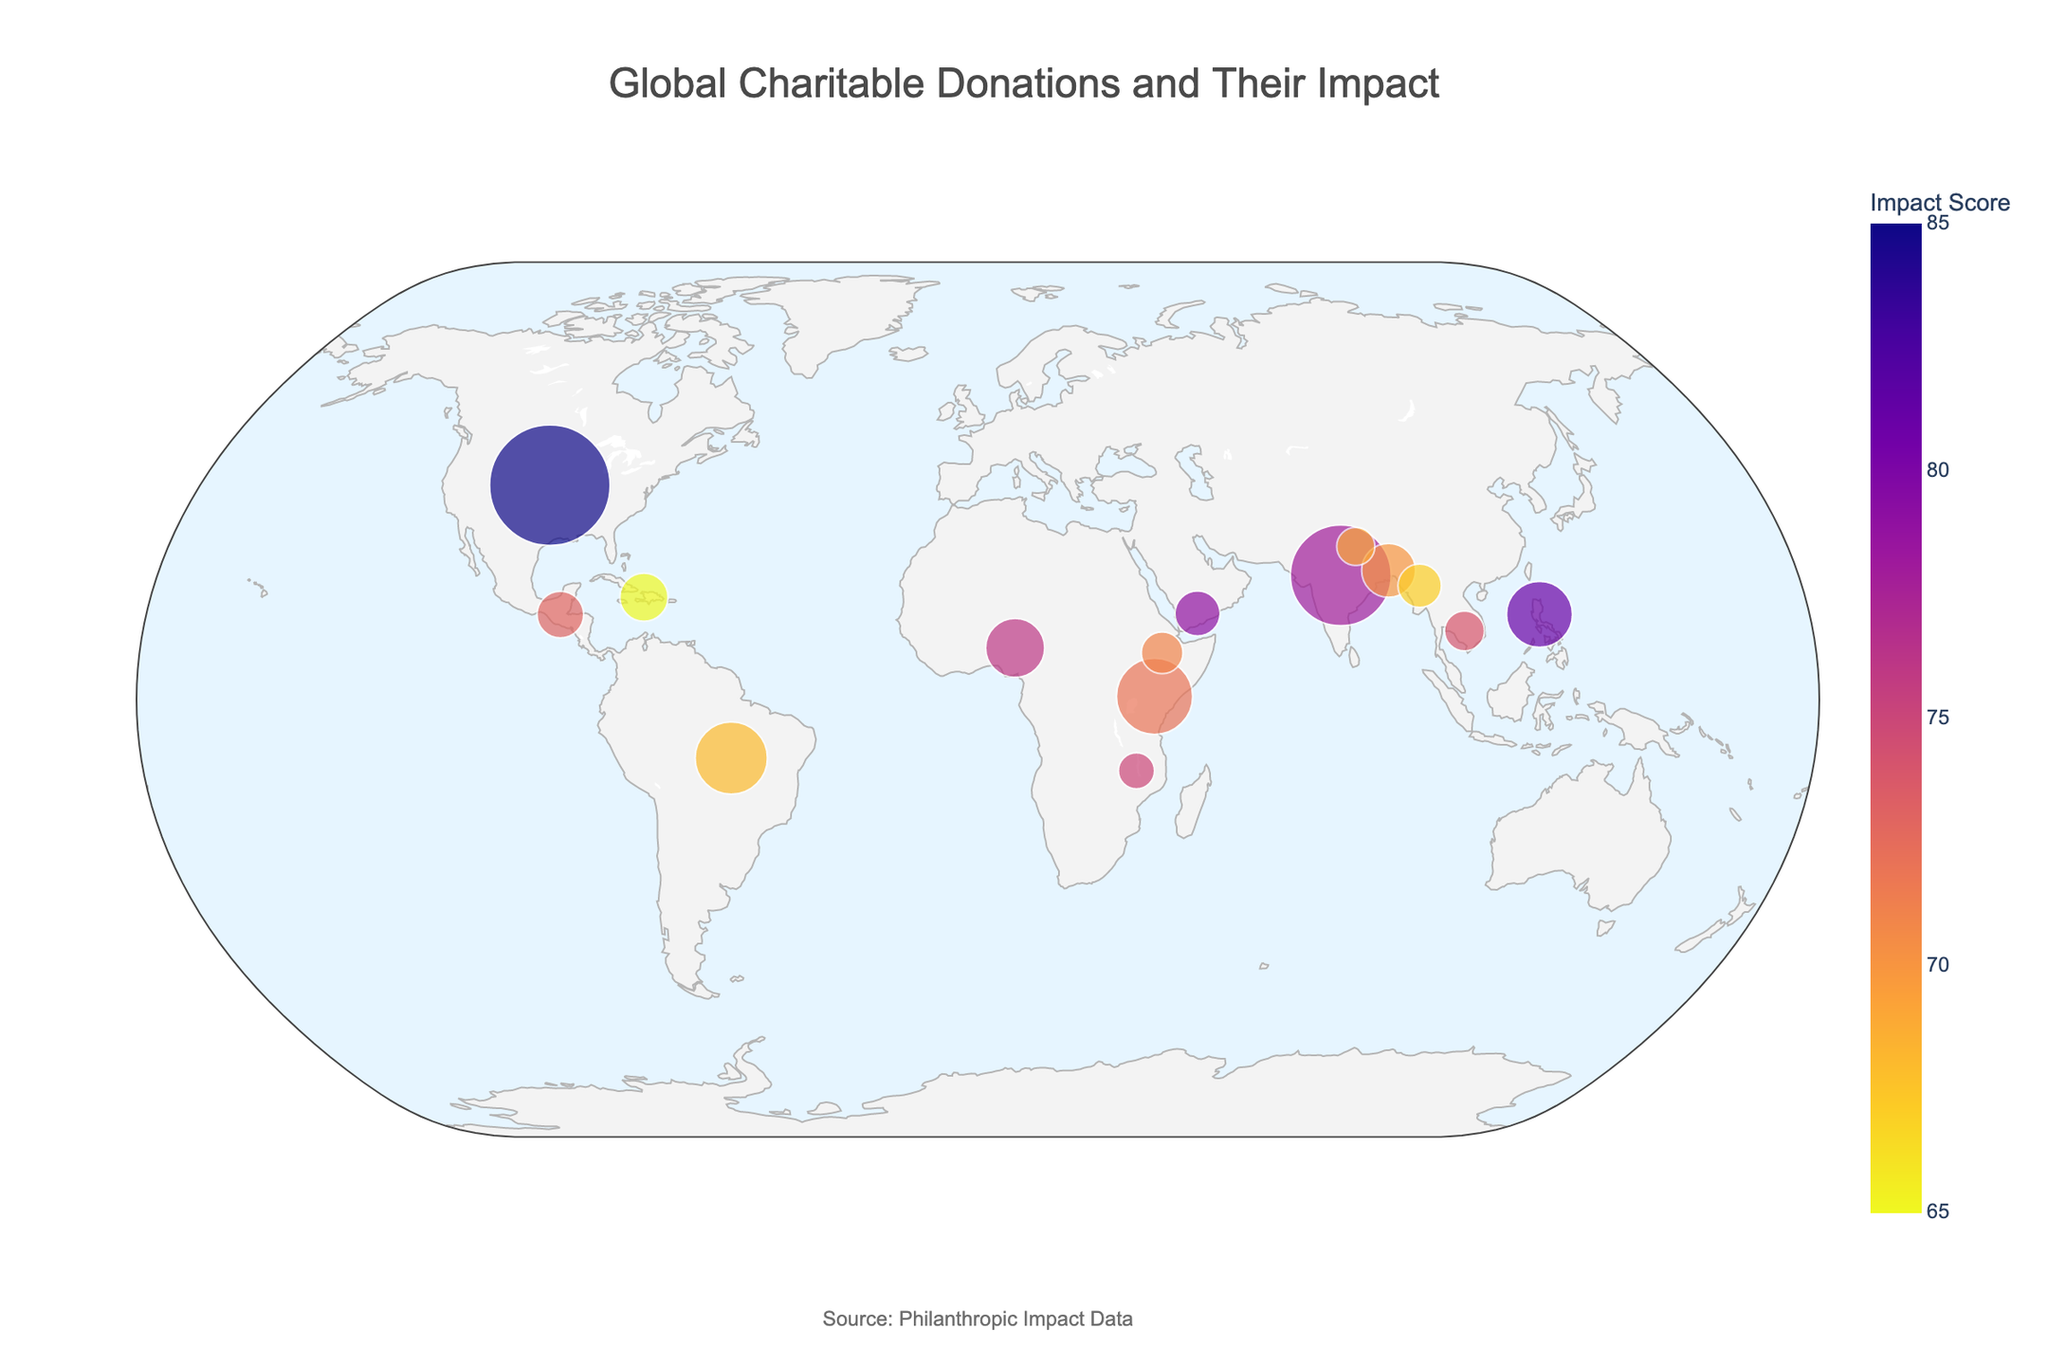What is the title of the figure? The title is typically placed prominently at the top of the figure. In this case, it states the main focus of the figure.
Answer: Global Charitable Donations and Their Impact What are the primary impact areas highlighted for donations in India and Kenya? By looking at the hover information of the points representing different countries, you can see the primary impact areas. For India, it is 'Healthcare' and for Kenya, it is 'Poverty Alleviation'.
Answer: Healthcare for India and Poverty Alleviation for Kenya How does the donation amount to the United States compare to that of Brazil? To compare donation amounts, check the sizes of the points on the map. The United States has a larger point compared to Brazil, meaning it received a higher donation amount. The specific amounts are $5,000,000 and $1,800,000, respectively.
Answer: The United States received more donations than Brazil What's the average Impact Score of donations made to Bangladesh, Guatemala, and Malawi? First, find the Impact Scores for each country: Bangladesh (70), Guatemala (73), and Malawi (75). Add these scores (70 + 73 + 75 = 218) and divide by the number of countries (218 / 3 = 72.67).
Answer: 72.67 Which country received the smallest donation amount? By looking at the smallest sized dot on the map and checking the hover information, the smallest donation amount is to Malawi, which is $450,000.
Answer: Malawi Which country targeting 'Child Welfare' has received donations and what is its Impact Score? Hover over the points to find the country targeting 'Child Welfare'. Guatemala is the country, and its Impact Score is 73.
Answer: Guatemala, Impact Score 73 Compare the Impact Scores of countries focusing on 'Clean Water Access' and 'Food Security'. Which one is higher? Check the hover information for the relevant countries: Nigeria for 'Clean Water Access' with a score of 76, and Bangladesh for 'Food Security' with a score of 70. Thus, Nigeria's score is higher.
Answer: Nigeria Which country received the second-highest donation and what primary issue does it address? The largest dot represents the highest donation, and the second largest represents the second-highest. India received the second-highest donation of $3,500,000, and the primary issue addressed is Healthcare.
Answer: India, Healthcare What's the total donated amount for countries with an Impact Score greater than 75? Identify countries with scores greater than 75: the United States (85), Philippines (81), Yemen (79), Nigeria (76), and Malawi (75 is not greater). Sum their donations (5,000,000 + 1,500,000 + 700,000 + 1,200,000 = 8,400,000).
Answer: $8,400,000 Which country focusing on 'Environmental Conservation' has received donations and what is its donated amount and Impact Score? Hover over the points to find the country focusing on 'Environmental Conservation'. Brazil is the country, with a donated amount of $1,800,000 and an Impact Score of 68.
Answer: Brazil, $1,800,000, Impact Score 68 